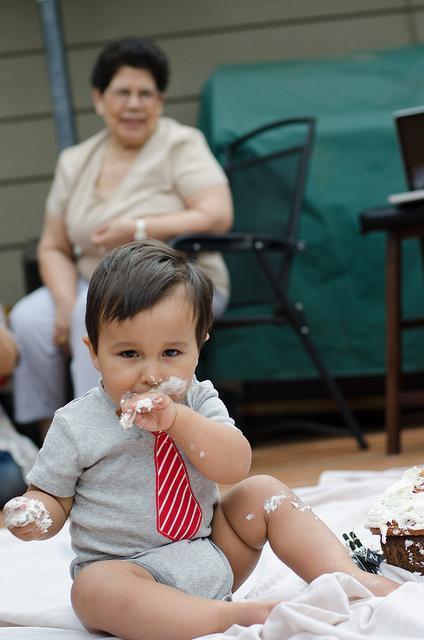How many fingers do the boy have in his mouth?
Give a very brief answer. 0. How many people are there?
Give a very brief answer. 2. How many laptops is there?
Give a very brief answer. 0. 